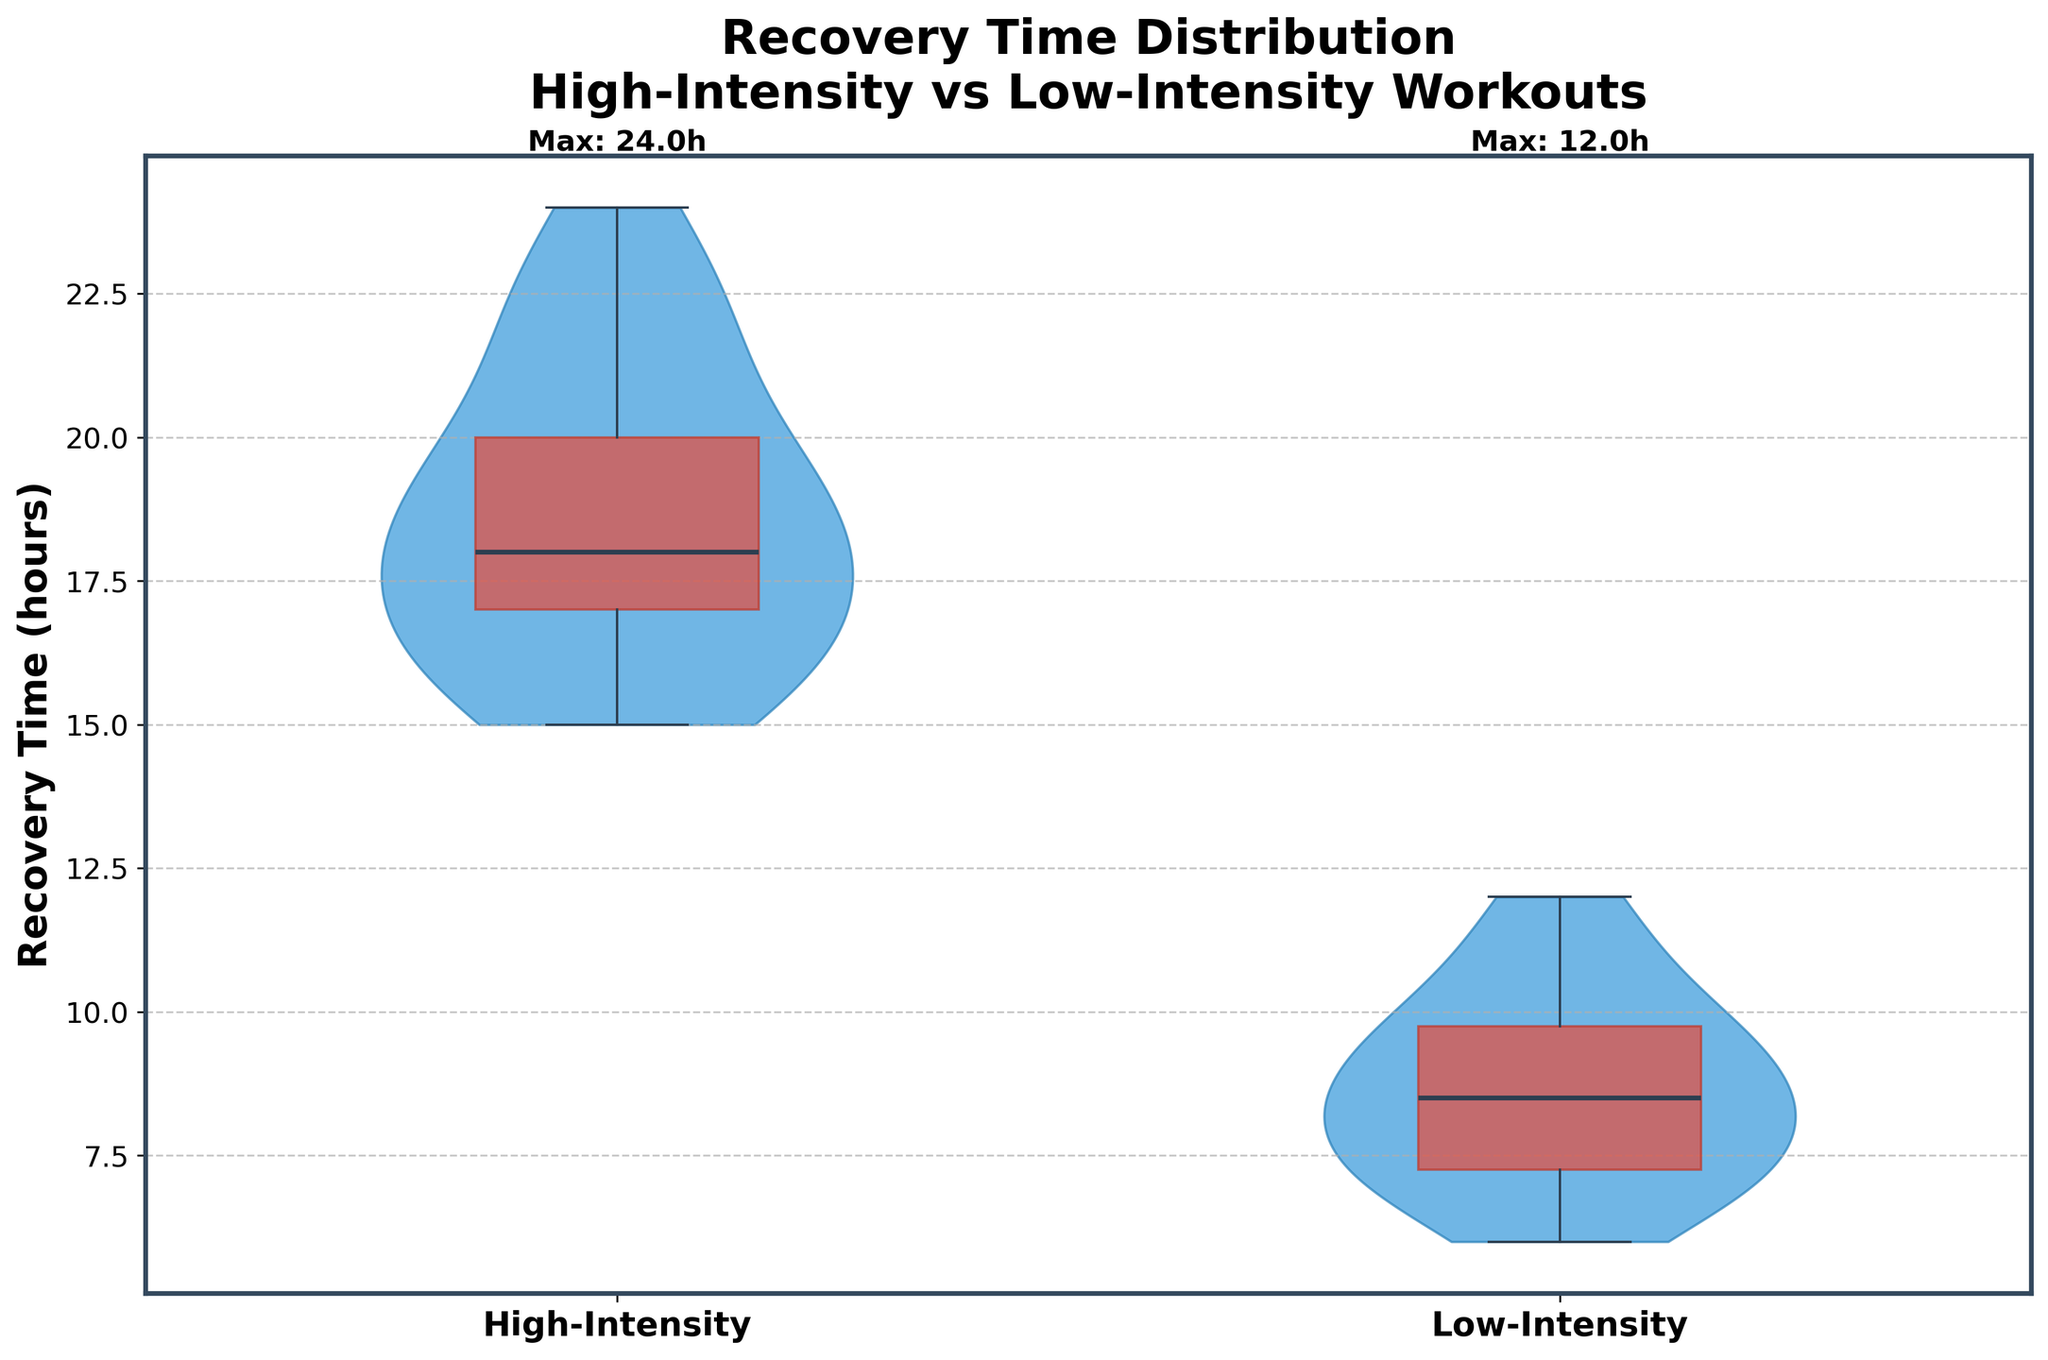What is the title of the figure? The title of a figure is usually displayed at the top. In this case, it reads "Recovery Time Distribution\nHigh-Intensity vs Low-Intensity Workouts".
Answer: Recovery Time Distribution\nHigh-Intensity vs Low-Intensity Workouts What are the two workout intensities compared in the figure? The x-axis labels represent the two categories being compared. Here, they are labeled as "High-Intensity" and "Low-Intensity".
Answer: High-Intensity and Low-Intensity Which workout intensity has a higher maximum recovery time? By looking at the text annotations at the top of each violin plot, the maximum values can be identified. High-Intensity has a maximum recovery time of 24 hours.
Answer: High-Intensity What is the color of the violins representing the recovery time distribution? The violins are filled with a specific color to distinguish the data. Here, they are a shade of blue.
Answer: Blue Which group shows a wider distribution of recovery times? The width of the violins indicates the distribution spread. High-Intensity workouts have a wider violin plot, indicating a larger spread in recovery times.
Answer: High-Intensity What is the range of recovery times after high-intensity workouts? By observing the top and bottom of the high-intensity violin plot, the range can be identified from approximately 15 to 24 hours.
Answer: 15 to 24 hours What is the median recovery time for low-intensity workouts? Box plots inside the violins show the median as a line inside the box. For low-intensity, the median line appears between 8 and 9 hours.
Answer: Between 8 and 9 hours Which intensity level has a higher level of consistency in recovery times? Consistency can be inferred from the spread. Low-Intensity shows a narrower distribution, indicating more consistent recovery times.
Answer: Low-Intensity Which workout intensity has its peak recovery times closer to the lower end of the range? The peak or bulkiest part of the violin plot suggests where most data points lie. Low-Intensity is bulkier towards the lower end of the range.
Answer: Low-Intensity If you want a shorter recovery time, which workout intensity should you opt for? Shorter recovery times can be inferred from the lower values in the violin plot. Low-Intensity has generally lower recovery times than High-Intensity.
Answer: Low-Intensity 